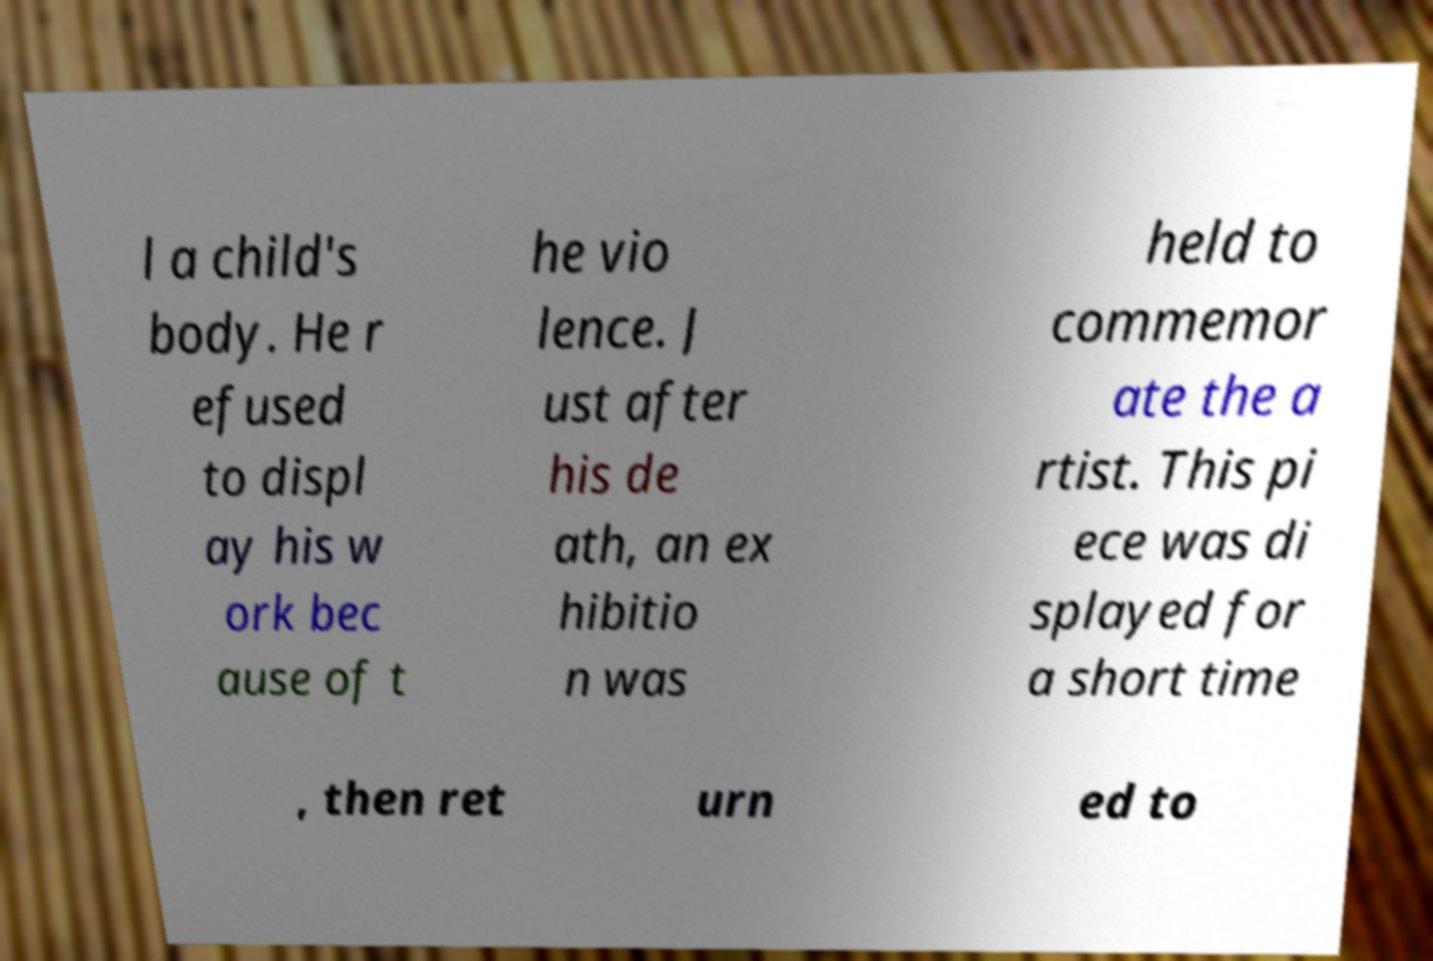Please identify and transcribe the text found in this image. l a child's body. He r efused to displ ay his w ork bec ause of t he vio lence. J ust after his de ath, an ex hibitio n was held to commemor ate the a rtist. This pi ece was di splayed for a short time , then ret urn ed to 